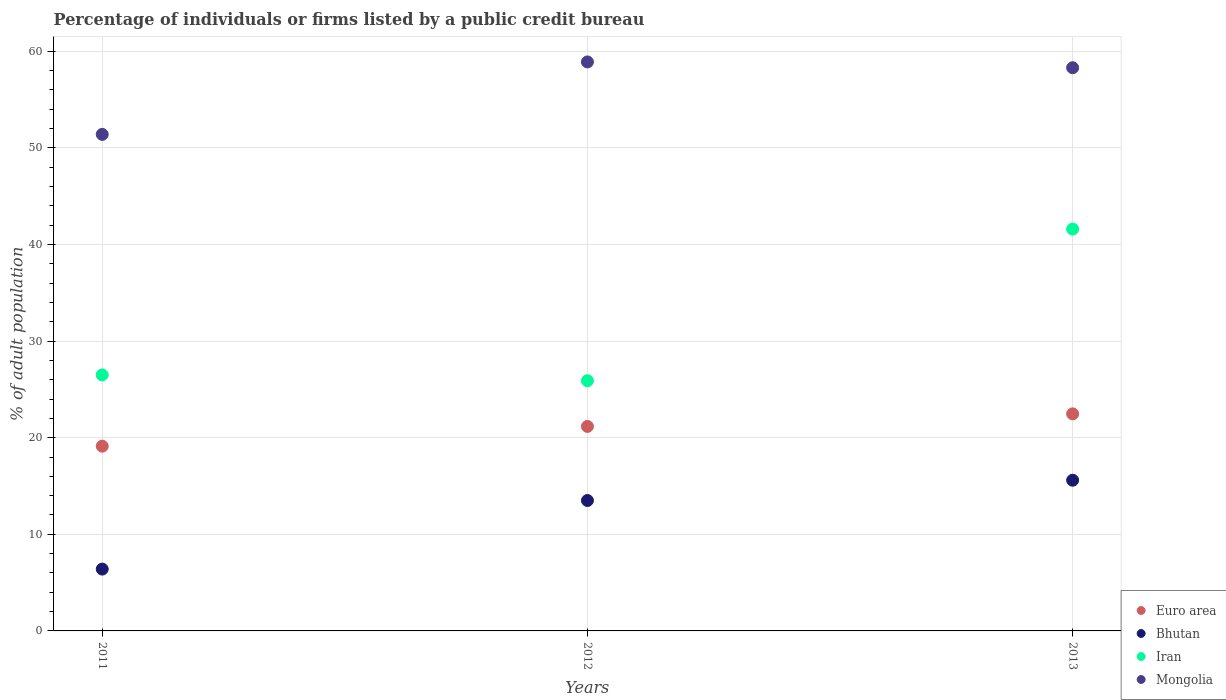How many different coloured dotlines are there?
Offer a very short reply. 4. What is the percentage of population listed by a public credit bureau in Euro area in 2011?
Your response must be concise. 19.13. Across all years, what is the maximum percentage of population listed by a public credit bureau in Mongolia?
Give a very brief answer. 58.9. Across all years, what is the minimum percentage of population listed by a public credit bureau in Iran?
Ensure brevity in your answer.  25.9. In which year was the percentage of population listed by a public credit bureau in Iran maximum?
Make the answer very short. 2013. What is the total percentage of population listed by a public credit bureau in Euro area in the graph?
Provide a short and direct response. 62.76. What is the difference between the percentage of population listed by a public credit bureau in Mongolia in 2011 and that in 2013?
Your response must be concise. -6.9. What is the difference between the percentage of population listed by a public credit bureau in Mongolia in 2011 and the percentage of population listed by a public credit bureau in Euro area in 2012?
Provide a succinct answer. 30.23. What is the average percentage of population listed by a public credit bureau in Iran per year?
Make the answer very short. 31.33. In the year 2012, what is the difference between the percentage of population listed by a public credit bureau in Mongolia and percentage of population listed by a public credit bureau in Bhutan?
Offer a terse response. 45.4. What is the ratio of the percentage of population listed by a public credit bureau in Iran in 2011 to that in 2012?
Your answer should be compact. 1.02. Is the difference between the percentage of population listed by a public credit bureau in Mongolia in 2012 and 2013 greater than the difference between the percentage of population listed by a public credit bureau in Bhutan in 2012 and 2013?
Offer a terse response. Yes. What is the difference between the highest and the second highest percentage of population listed by a public credit bureau in Iran?
Offer a very short reply. 15.1. In how many years, is the percentage of population listed by a public credit bureau in Bhutan greater than the average percentage of population listed by a public credit bureau in Bhutan taken over all years?
Offer a terse response. 2. Is it the case that in every year, the sum of the percentage of population listed by a public credit bureau in Bhutan and percentage of population listed by a public credit bureau in Euro area  is greater than the sum of percentage of population listed by a public credit bureau in Mongolia and percentage of population listed by a public credit bureau in Iran?
Keep it short and to the point. No. Is it the case that in every year, the sum of the percentage of population listed by a public credit bureau in Mongolia and percentage of population listed by a public credit bureau in Bhutan  is greater than the percentage of population listed by a public credit bureau in Euro area?
Your answer should be very brief. Yes. Does the percentage of population listed by a public credit bureau in Euro area monotonically increase over the years?
Keep it short and to the point. Yes. Are the values on the major ticks of Y-axis written in scientific E-notation?
Keep it short and to the point. No. How are the legend labels stacked?
Keep it short and to the point. Vertical. What is the title of the graph?
Offer a very short reply. Percentage of individuals or firms listed by a public credit bureau. What is the label or title of the X-axis?
Your answer should be very brief. Years. What is the label or title of the Y-axis?
Ensure brevity in your answer.  % of adult population. What is the % of adult population of Euro area in 2011?
Ensure brevity in your answer.  19.13. What is the % of adult population of Bhutan in 2011?
Provide a short and direct response. 6.4. What is the % of adult population in Iran in 2011?
Your answer should be very brief. 26.5. What is the % of adult population of Mongolia in 2011?
Your answer should be compact. 51.4. What is the % of adult population in Euro area in 2012?
Your response must be concise. 21.17. What is the % of adult population in Bhutan in 2012?
Offer a very short reply. 13.5. What is the % of adult population in Iran in 2012?
Your response must be concise. 25.9. What is the % of adult population in Mongolia in 2012?
Keep it short and to the point. 58.9. What is the % of adult population of Euro area in 2013?
Offer a terse response. 22.47. What is the % of adult population of Bhutan in 2013?
Provide a succinct answer. 15.6. What is the % of adult population of Iran in 2013?
Offer a very short reply. 41.6. What is the % of adult population of Mongolia in 2013?
Make the answer very short. 58.3. Across all years, what is the maximum % of adult population of Euro area?
Keep it short and to the point. 22.47. Across all years, what is the maximum % of adult population in Bhutan?
Provide a succinct answer. 15.6. Across all years, what is the maximum % of adult population in Iran?
Your answer should be compact. 41.6. Across all years, what is the maximum % of adult population of Mongolia?
Provide a short and direct response. 58.9. Across all years, what is the minimum % of adult population in Euro area?
Provide a short and direct response. 19.13. Across all years, what is the minimum % of adult population of Iran?
Ensure brevity in your answer.  25.9. Across all years, what is the minimum % of adult population of Mongolia?
Keep it short and to the point. 51.4. What is the total % of adult population in Euro area in the graph?
Your answer should be compact. 62.76. What is the total % of adult population in Bhutan in the graph?
Your answer should be compact. 35.5. What is the total % of adult population of Iran in the graph?
Make the answer very short. 94. What is the total % of adult population in Mongolia in the graph?
Your response must be concise. 168.6. What is the difference between the % of adult population in Euro area in 2011 and that in 2012?
Ensure brevity in your answer.  -2.04. What is the difference between the % of adult population of Iran in 2011 and that in 2012?
Provide a succinct answer. 0.6. What is the difference between the % of adult population in Mongolia in 2011 and that in 2012?
Your answer should be compact. -7.5. What is the difference between the % of adult population in Euro area in 2011 and that in 2013?
Your answer should be very brief. -3.34. What is the difference between the % of adult population of Iran in 2011 and that in 2013?
Give a very brief answer. -15.1. What is the difference between the % of adult population of Euro area in 2012 and that in 2013?
Offer a very short reply. -1.3. What is the difference between the % of adult population of Bhutan in 2012 and that in 2013?
Keep it short and to the point. -2.1. What is the difference between the % of adult population of Iran in 2012 and that in 2013?
Your answer should be compact. -15.7. What is the difference between the % of adult population in Euro area in 2011 and the % of adult population in Bhutan in 2012?
Make the answer very short. 5.63. What is the difference between the % of adult population in Euro area in 2011 and the % of adult population in Iran in 2012?
Provide a short and direct response. -6.77. What is the difference between the % of adult population of Euro area in 2011 and the % of adult population of Mongolia in 2012?
Give a very brief answer. -39.77. What is the difference between the % of adult population in Bhutan in 2011 and the % of adult population in Iran in 2012?
Give a very brief answer. -19.5. What is the difference between the % of adult population of Bhutan in 2011 and the % of adult population of Mongolia in 2012?
Ensure brevity in your answer.  -52.5. What is the difference between the % of adult population of Iran in 2011 and the % of adult population of Mongolia in 2012?
Provide a short and direct response. -32.4. What is the difference between the % of adult population in Euro area in 2011 and the % of adult population in Bhutan in 2013?
Provide a succinct answer. 3.53. What is the difference between the % of adult population in Euro area in 2011 and the % of adult population in Iran in 2013?
Provide a succinct answer. -22.47. What is the difference between the % of adult population in Euro area in 2011 and the % of adult population in Mongolia in 2013?
Offer a terse response. -39.17. What is the difference between the % of adult population in Bhutan in 2011 and the % of adult population in Iran in 2013?
Provide a succinct answer. -35.2. What is the difference between the % of adult population of Bhutan in 2011 and the % of adult population of Mongolia in 2013?
Offer a very short reply. -51.9. What is the difference between the % of adult population in Iran in 2011 and the % of adult population in Mongolia in 2013?
Give a very brief answer. -31.8. What is the difference between the % of adult population in Euro area in 2012 and the % of adult population in Bhutan in 2013?
Provide a succinct answer. 5.57. What is the difference between the % of adult population in Euro area in 2012 and the % of adult population in Iran in 2013?
Make the answer very short. -20.43. What is the difference between the % of adult population of Euro area in 2012 and the % of adult population of Mongolia in 2013?
Offer a terse response. -37.13. What is the difference between the % of adult population of Bhutan in 2012 and the % of adult population of Iran in 2013?
Keep it short and to the point. -28.1. What is the difference between the % of adult population of Bhutan in 2012 and the % of adult population of Mongolia in 2013?
Make the answer very short. -44.8. What is the difference between the % of adult population of Iran in 2012 and the % of adult population of Mongolia in 2013?
Keep it short and to the point. -32.4. What is the average % of adult population of Euro area per year?
Give a very brief answer. 20.92. What is the average % of adult population in Bhutan per year?
Ensure brevity in your answer.  11.83. What is the average % of adult population of Iran per year?
Your answer should be very brief. 31.33. What is the average % of adult population in Mongolia per year?
Your answer should be very brief. 56.2. In the year 2011, what is the difference between the % of adult population in Euro area and % of adult population in Bhutan?
Your answer should be compact. 12.73. In the year 2011, what is the difference between the % of adult population in Euro area and % of adult population in Iran?
Provide a succinct answer. -7.37. In the year 2011, what is the difference between the % of adult population of Euro area and % of adult population of Mongolia?
Make the answer very short. -32.27. In the year 2011, what is the difference between the % of adult population of Bhutan and % of adult population of Iran?
Your answer should be very brief. -20.1. In the year 2011, what is the difference between the % of adult population in Bhutan and % of adult population in Mongolia?
Offer a very short reply. -45. In the year 2011, what is the difference between the % of adult population in Iran and % of adult population in Mongolia?
Offer a terse response. -24.9. In the year 2012, what is the difference between the % of adult population in Euro area and % of adult population in Bhutan?
Your response must be concise. 7.67. In the year 2012, what is the difference between the % of adult population in Euro area and % of adult population in Iran?
Keep it short and to the point. -4.73. In the year 2012, what is the difference between the % of adult population of Euro area and % of adult population of Mongolia?
Ensure brevity in your answer.  -37.73. In the year 2012, what is the difference between the % of adult population of Bhutan and % of adult population of Mongolia?
Your response must be concise. -45.4. In the year 2012, what is the difference between the % of adult population of Iran and % of adult population of Mongolia?
Your response must be concise. -33. In the year 2013, what is the difference between the % of adult population of Euro area and % of adult population of Bhutan?
Offer a very short reply. 6.87. In the year 2013, what is the difference between the % of adult population of Euro area and % of adult population of Iran?
Provide a short and direct response. -19.13. In the year 2013, what is the difference between the % of adult population of Euro area and % of adult population of Mongolia?
Your response must be concise. -35.83. In the year 2013, what is the difference between the % of adult population in Bhutan and % of adult population in Mongolia?
Provide a short and direct response. -42.7. In the year 2013, what is the difference between the % of adult population in Iran and % of adult population in Mongolia?
Offer a very short reply. -16.7. What is the ratio of the % of adult population in Euro area in 2011 to that in 2012?
Ensure brevity in your answer.  0.9. What is the ratio of the % of adult population of Bhutan in 2011 to that in 2012?
Offer a terse response. 0.47. What is the ratio of the % of adult population in Iran in 2011 to that in 2012?
Offer a terse response. 1.02. What is the ratio of the % of adult population in Mongolia in 2011 to that in 2012?
Keep it short and to the point. 0.87. What is the ratio of the % of adult population in Euro area in 2011 to that in 2013?
Provide a succinct answer. 0.85. What is the ratio of the % of adult population in Bhutan in 2011 to that in 2013?
Give a very brief answer. 0.41. What is the ratio of the % of adult population of Iran in 2011 to that in 2013?
Your response must be concise. 0.64. What is the ratio of the % of adult population in Mongolia in 2011 to that in 2013?
Offer a terse response. 0.88. What is the ratio of the % of adult population of Euro area in 2012 to that in 2013?
Give a very brief answer. 0.94. What is the ratio of the % of adult population of Bhutan in 2012 to that in 2013?
Give a very brief answer. 0.87. What is the ratio of the % of adult population in Iran in 2012 to that in 2013?
Your answer should be very brief. 0.62. What is the ratio of the % of adult population of Mongolia in 2012 to that in 2013?
Your response must be concise. 1.01. What is the difference between the highest and the second highest % of adult population in Euro area?
Provide a succinct answer. 1.3. What is the difference between the highest and the second highest % of adult population in Bhutan?
Give a very brief answer. 2.1. What is the difference between the highest and the second highest % of adult population of Mongolia?
Offer a terse response. 0.6. What is the difference between the highest and the lowest % of adult population in Euro area?
Provide a short and direct response. 3.34. What is the difference between the highest and the lowest % of adult population of Bhutan?
Provide a succinct answer. 9.2. What is the difference between the highest and the lowest % of adult population of Iran?
Your answer should be very brief. 15.7. What is the difference between the highest and the lowest % of adult population in Mongolia?
Your response must be concise. 7.5. 